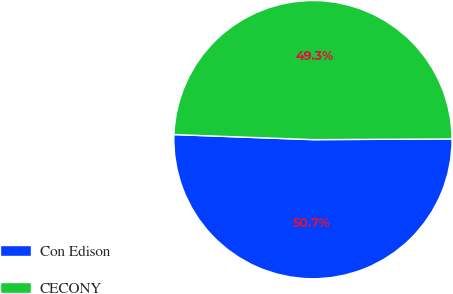Convert chart to OTSL. <chart><loc_0><loc_0><loc_500><loc_500><pie_chart><fcel>Con Edison<fcel>CECONY<nl><fcel>50.66%<fcel>49.34%<nl></chart> 